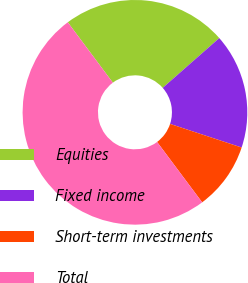Convert chart to OTSL. <chart><loc_0><loc_0><loc_500><loc_500><pie_chart><fcel>Equities<fcel>Fixed income<fcel>Short-term investments<fcel>Total<nl><fcel>23.71%<fcel>16.56%<fcel>9.72%<fcel>50.0%<nl></chart> 